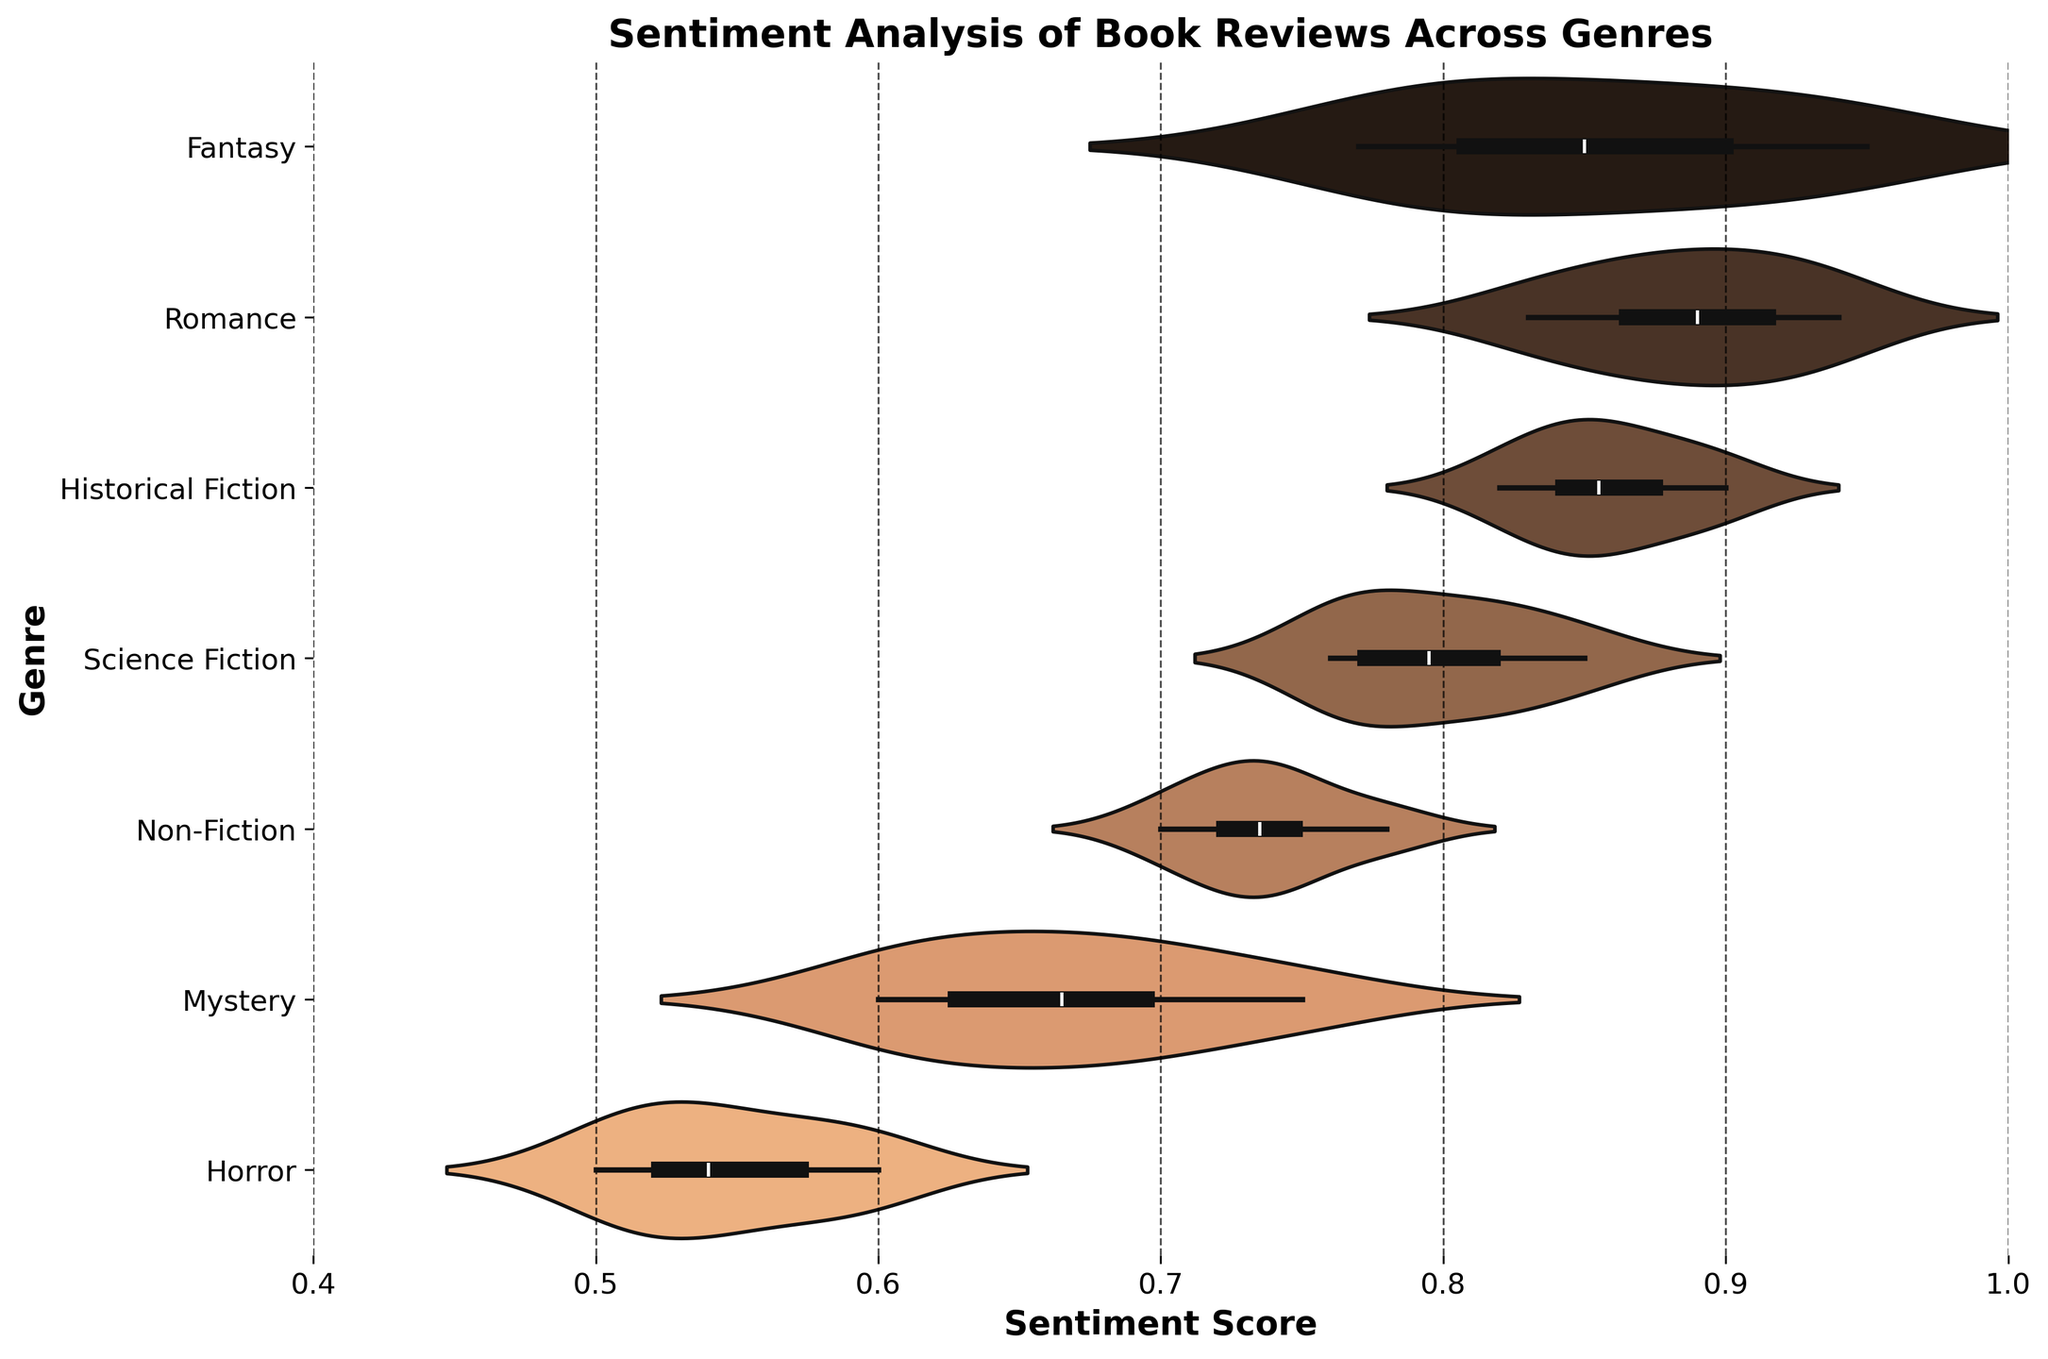What is the title of the figure? The title of the figure is displayed at the top of the plot. It reads "Sentiment Analysis of Book Reviews Across Genres."
Answer: Sentiment Analysis of Book Reviews Across Genres What does the x-axis represent? The x-axis of the plot is labeled "Sentiment Score," indicating that it represents the sentiment score of book reviews.
Answer: Sentiment Score Which genre has the highest median sentiment score? The median sentiment score of each genre is represented by the white dot in each violin plot. For the Romance genre, the white dot is positioned higher on the sentiment score axis compared to other genres, indicating that it has the highest median sentiment score.
Answer: Romance Which genre shows the widest range of sentiment scores? The width and spread of each violin plot represent the distribution of sentiment scores within a genre. The Horror genre displays the widest range, evidenced by the greater spread of the violin plot along the x-axis.
Answer: Horror How does the sentiment score distribution for Fantasy compare to Non-Fiction? The Fantasy genre shows a higher concentration of sentiment scores towards the upper end (e.g., above 0.8), whereas Non-Fiction has a more spread out distribution with values ranging from 0.70 to 0.78.
Answer: Fantasy has higher sentiment scores What is the approximate average sentiment score for the Mystery genre? By observing the density of the Mystery violin plot, the sentiment scores are relatively centered around 0.65-0.70. Averaging the central values gives approximately (0.65 + 0.70) / 2 = 0.675.
Answer: 0.675 How does the sentiment score for Historical Fiction generally compare to Science Fiction? The median scores for both genres are compared by checking the positions of the white dots. Historical Fiction has a slightly higher median score than Science Fiction, but both distributions are relatively high on the sentiment score axis.
Answer: Historical Fiction has slightly higher scores What unique feature does the violin plot for Horror have compared to other genres? The Horror genre's violin plot has a unique feature of having the lowest sentiment scores and the most spread-out distribution, covering a wider range from approximately 0.50 to 0.60.
Answer: Most spread-out and lowest scores What is the lower bound of the sentiment score range for Romance? The lower bound of the sentiment score for the Romance violin plot can be identified as the minimum point where the plot starts, which is around 0.83.
Answer: 0.83 Which genres exhibit a sentiment score above 0.9? By looking at the extreme right end of the x-axis, the genres Fantasy, Romance, and Historical Fiction exhibit sentiment scores above 0.9.
Answer: Fantasy, Romance, Historical Fiction 